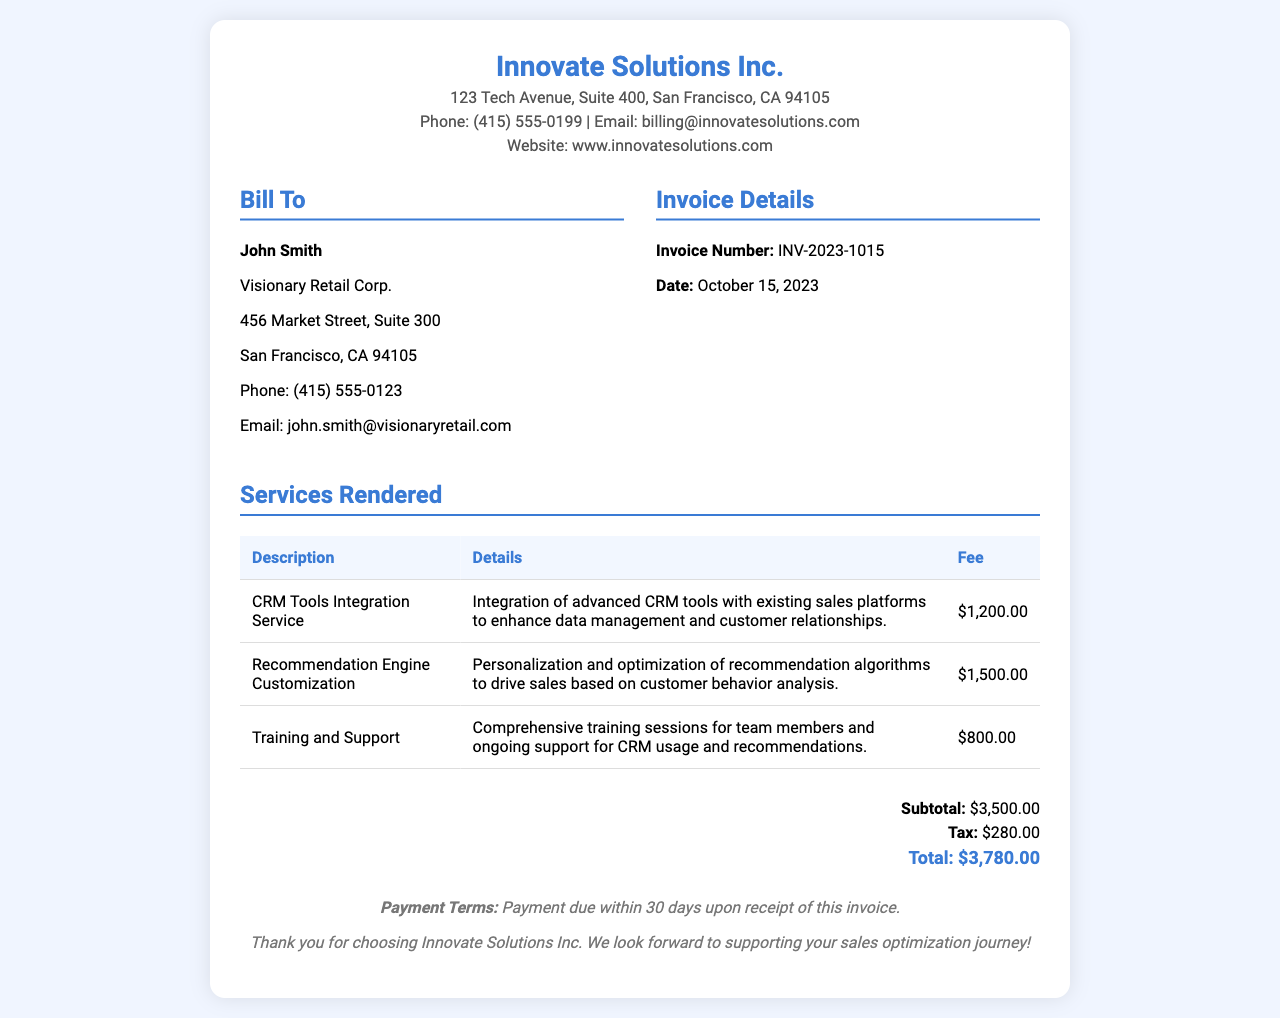what is the name of the company that issued the receipt? The name of the company is listed at the top of the receipt.
Answer: Innovate Solutions Inc who is the recipient of the services? The recipient of the services is indicated in the billing section.
Answer: John Smith what is the invoice number? The invoice number is mentioned in the invoice details section.
Answer: INV-2023-1015 how much is the fee for the CRM Tools Integration Service? The fee for the CRM Tools Integration Service is specified in the services rendered table.
Answer: $1,200.00 what is the total amount due? The total amount is calculated at the bottom of the receipt, including subtotal and tax.
Answer: $3,780.00 when is the payment due? Payment terms are stated in the footer of the receipt.
Answer: within 30 days what service costs the most? Identifying the most expensive service requires comparing the fees listed in the table.
Answer: Recommendation Engine Customization how much is the tax applied? The tax amount is summarized in the total section of the receipt.
Answer: $280.00 what is the purpose of the Training and Support service? The purpose of the Training and Support service is detailed in the services rendered table.
Answer: Comprehensive training sessions for team members and ongoing support for CRM usage and recommendations 